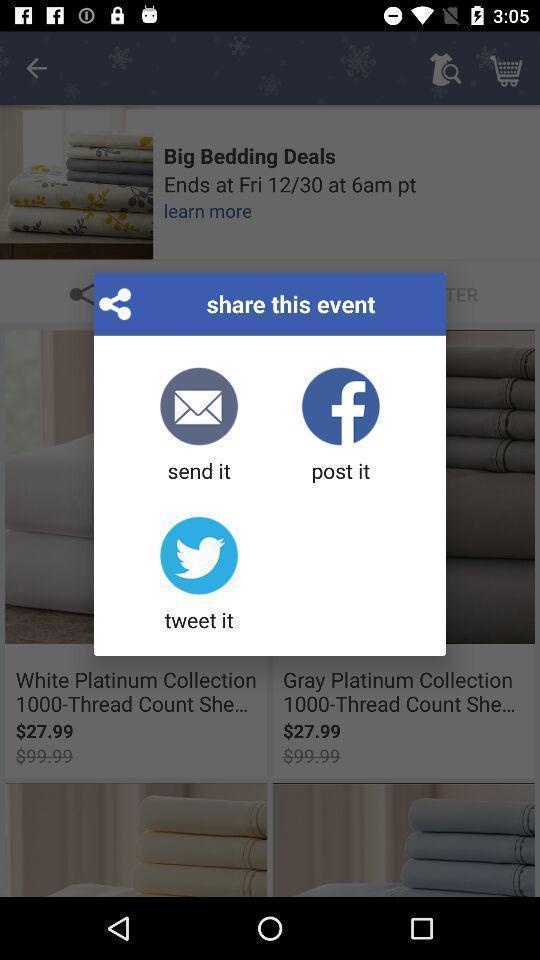Tell me about the visual elements in this screen capture. Pop up window with different sharing options. 